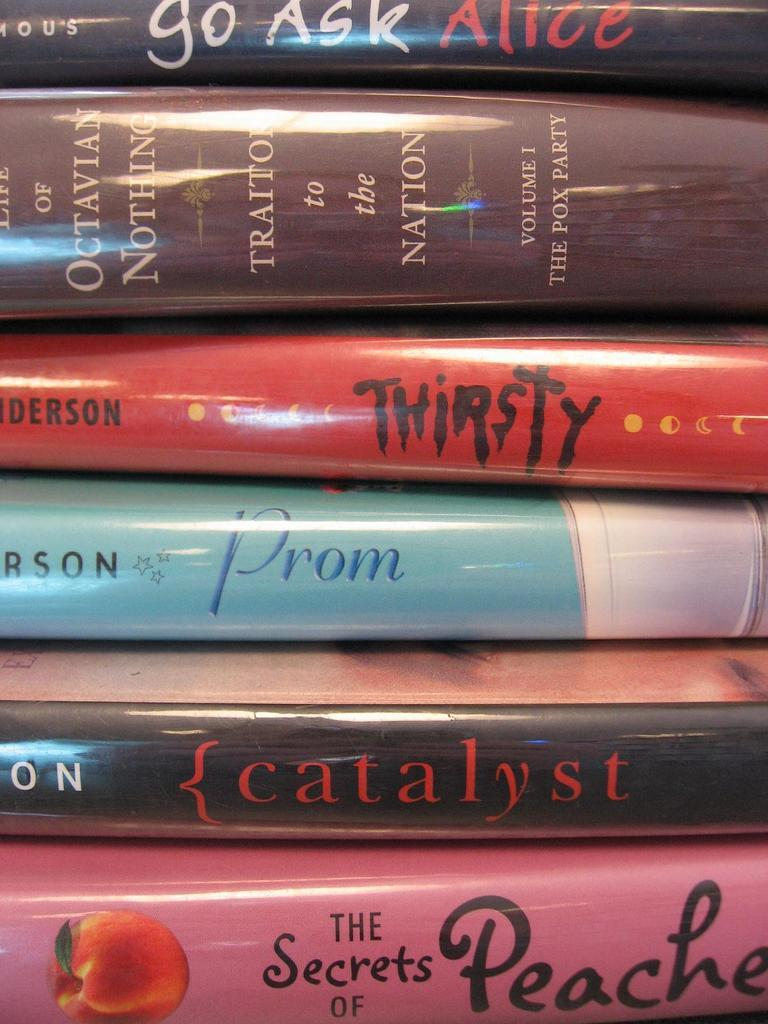<image>
Share a concise interpretation of the image provided. a stack of several books including Prom, Thirsty, and {Catalyst 